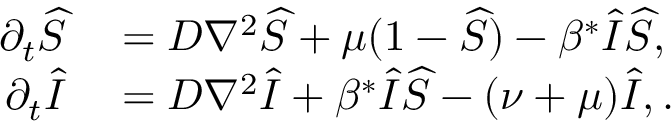Convert formula to latex. <formula><loc_0><loc_0><loc_500><loc_500>\begin{array} { r l } { \partial _ { t } \widehat { S } } & = D \nabla ^ { 2 } \widehat { S } + \mu ( 1 - \widehat { S } ) - \beta ^ { * } \widehat { I } \widehat { S } , } \\ { \partial _ { t } \widehat { I } } & = D \nabla ^ { 2 } \widehat { I } + \beta ^ { * } \widehat { I } \widehat { S } - ( \nu + \mu ) \widehat { I } , . } \end{array}</formula> 